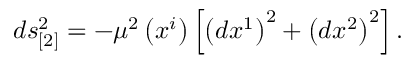Convert formula to latex. <formula><loc_0><loc_0><loc_500><loc_500>d s _ { [ 2 ] } ^ { 2 } = - \mu ^ { 2 } \left ( x ^ { i } \right ) \left [ \left ( d x ^ { 1 } \right ) ^ { 2 } + \left ( d x ^ { 2 } \right ) ^ { 2 } \right ] .</formula> 